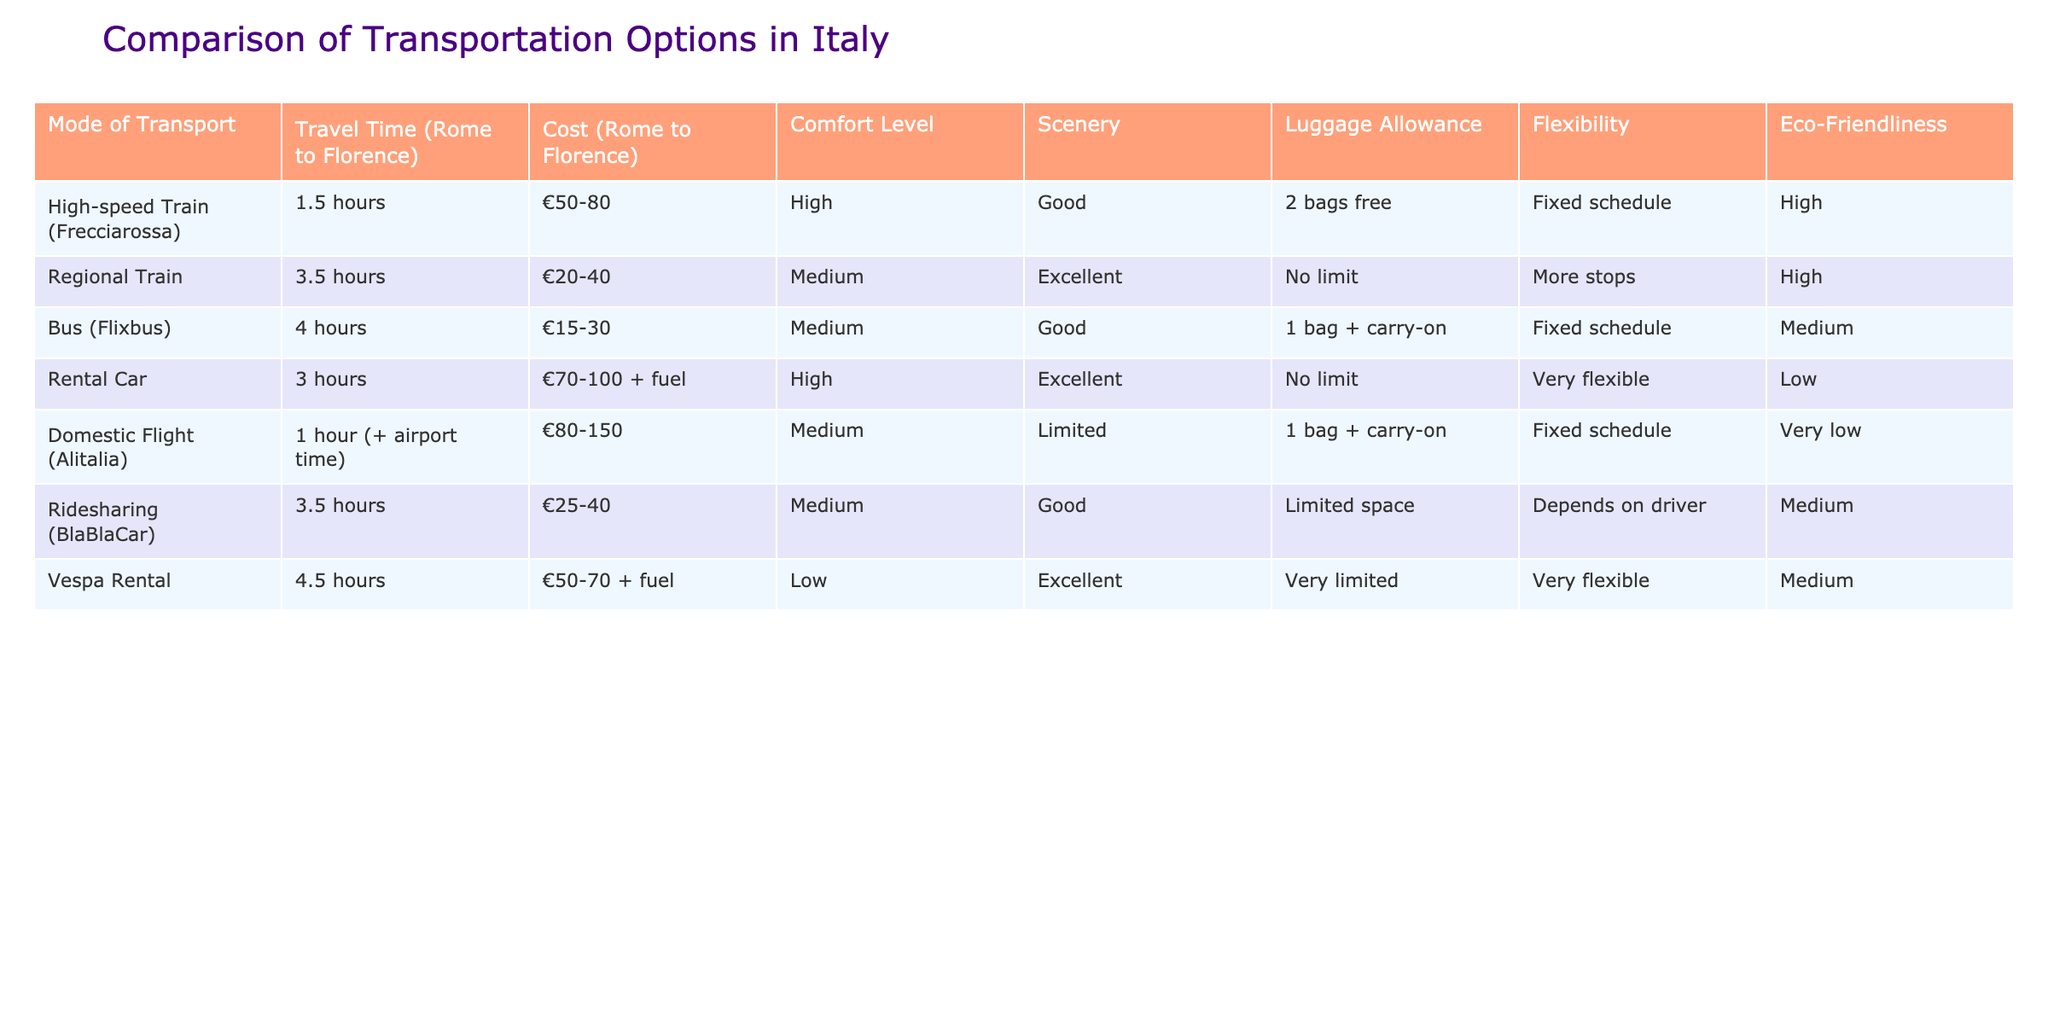What is the travel time by high-speed train from Rome to Florence? According to the table, the travel time by high-speed train (Frecciarossa) from Rome to Florence is listed as 1.5 hours.
Answer: 1.5 hours What is the cost range of the regional train from Rome to Florence? The table shows that the cost of the regional train from Rome to Florence ranges from €20 to €40.
Answer: €20-40 Is the luggage allowance for the domestic flight different from the high-speed train? The domestic flight allows 1 bag plus carry-on, while the high-speed train allows 2 bags free. Therefore, yes, the luggage allowances are different.
Answer: Yes Which transportation option has the highest comfort level? The table indicates that the high-speed train (Frecciarossa) has a high comfort level, which is the highest among the options listed.
Answer: High-speed train (Frecciarossa) What is the average cost of traveling by bus and ridesharing? The average cost of the bus (Flixbus) is €22.5, and the ridesharing (BlaBlaCar) is between €25 and €40, making an average cost of approximately €32.5 when calculated as (€22.5 + (€25 + €40)/2).
Answer: €32.5 Which transport mode is the most eco-friendly? The table indicates that the high-speed train has a high level of eco-friendliness, making it the most eco-friendly transport option listed.
Answer: High-speed train (Frecciarossa) Does the vespa rental have more flexibility than the regional train? Yes, the vespa rental is marked as very flexible, while the regional train has more stops, indicating less flexibility.
Answer: Yes What is the total travel time for a domestic flight when factoring in airport time? The table states that the domestic flight takes 1 hour plus airport time, so including typical airport processing time, it can be considered more than 1 hour. For exact travel time, additional airport time needs to be assumed, typically 1-2 hours.
Answer: More than 1 hour Which of the transport options has the best scenery according to the table? The regional train is noted for having excellent scenery, making it the option with the best views based on the data presented.
Answer: Regional train 